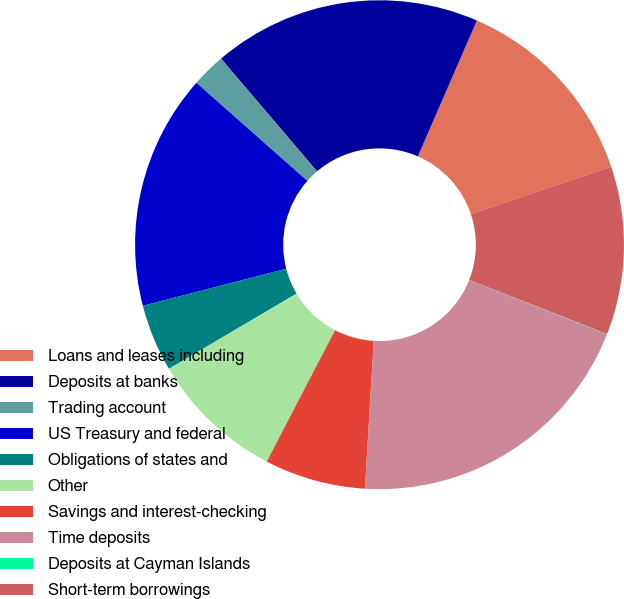<chart> <loc_0><loc_0><loc_500><loc_500><pie_chart><fcel>Loans and leases including<fcel>Deposits at banks<fcel>Trading account<fcel>US Treasury and federal<fcel>Obligations of states and<fcel>Other<fcel>Savings and interest-checking<fcel>Time deposits<fcel>Deposits at Cayman Islands<fcel>Short-term borrowings<nl><fcel>13.32%<fcel>17.75%<fcel>2.25%<fcel>15.54%<fcel>4.46%<fcel>8.89%<fcel>6.68%<fcel>19.97%<fcel>0.03%<fcel>11.11%<nl></chart> 